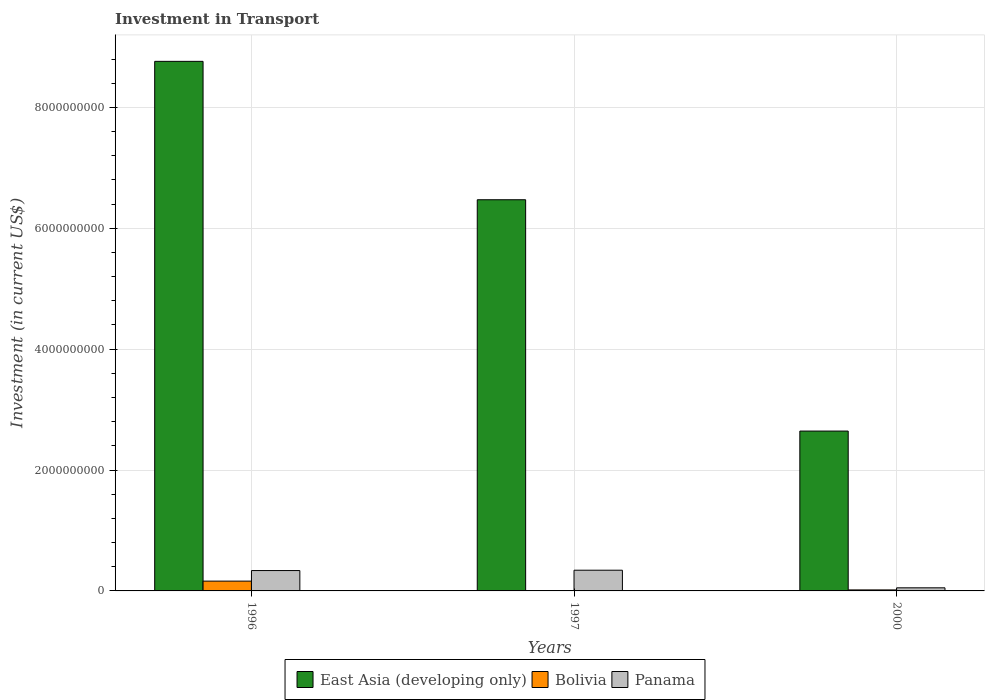Are the number of bars per tick equal to the number of legend labels?
Provide a succinct answer. Yes. Are the number of bars on each tick of the X-axis equal?
Your answer should be compact. Yes. How many bars are there on the 3rd tick from the right?
Your answer should be very brief. 3. In how many cases, is the number of bars for a given year not equal to the number of legend labels?
Provide a short and direct response. 0. What is the amount invested in transport in Bolivia in 1997?
Provide a succinct answer. 6.60e+06. Across all years, what is the maximum amount invested in transport in Panama?
Provide a succinct answer. 3.43e+08. Across all years, what is the minimum amount invested in transport in Bolivia?
Make the answer very short. 6.60e+06. In which year was the amount invested in transport in East Asia (developing only) maximum?
Keep it short and to the point. 1996. What is the total amount invested in transport in Panama in the graph?
Give a very brief answer. 7.31e+08. What is the difference between the amount invested in transport in East Asia (developing only) in 1996 and that in 2000?
Ensure brevity in your answer.  6.12e+09. What is the difference between the amount invested in transport in Bolivia in 2000 and the amount invested in transport in East Asia (developing only) in 1996?
Your answer should be compact. -8.74e+09. What is the average amount invested in transport in Bolivia per year?
Your response must be concise. 6.18e+07. In the year 1996, what is the difference between the amount invested in transport in Bolivia and amount invested in transport in East Asia (developing only)?
Make the answer very short. -8.60e+09. What is the ratio of the amount invested in transport in Panama in 1996 to that in 1997?
Ensure brevity in your answer.  0.98. Is the amount invested in transport in Bolivia in 1996 less than that in 1997?
Your response must be concise. No. What is the difference between the highest and the second highest amount invested in transport in Bolivia?
Make the answer very short. 1.46e+08. What is the difference between the highest and the lowest amount invested in transport in East Asia (developing only)?
Your response must be concise. 6.12e+09. What does the 1st bar from the left in 1997 represents?
Ensure brevity in your answer.  East Asia (developing only). What does the 3rd bar from the right in 2000 represents?
Keep it short and to the point. East Asia (developing only). How many years are there in the graph?
Provide a succinct answer. 3. What is the difference between two consecutive major ticks on the Y-axis?
Offer a very short reply. 2.00e+09. Does the graph contain any zero values?
Your response must be concise. No. How many legend labels are there?
Keep it short and to the point. 3. How are the legend labels stacked?
Ensure brevity in your answer.  Horizontal. What is the title of the graph?
Ensure brevity in your answer.  Investment in Transport. What is the label or title of the X-axis?
Provide a succinct answer. Years. What is the label or title of the Y-axis?
Make the answer very short. Investment (in current US$). What is the Investment (in current US$) in East Asia (developing only) in 1996?
Offer a very short reply. 8.76e+09. What is the Investment (in current US$) of Bolivia in 1996?
Keep it short and to the point. 1.62e+08. What is the Investment (in current US$) in Panama in 1996?
Give a very brief answer. 3.37e+08. What is the Investment (in current US$) of East Asia (developing only) in 1997?
Keep it short and to the point. 6.47e+09. What is the Investment (in current US$) of Bolivia in 1997?
Your answer should be compact. 6.60e+06. What is the Investment (in current US$) of Panama in 1997?
Provide a short and direct response. 3.43e+08. What is the Investment (in current US$) in East Asia (developing only) in 2000?
Give a very brief answer. 2.64e+09. What is the Investment (in current US$) of Bolivia in 2000?
Your answer should be very brief. 1.66e+07. What is the Investment (in current US$) in Panama in 2000?
Provide a succinct answer. 5.14e+07. Across all years, what is the maximum Investment (in current US$) of East Asia (developing only)?
Provide a short and direct response. 8.76e+09. Across all years, what is the maximum Investment (in current US$) in Bolivia?
Your response must be concise. 1.62e+08. Across all years, what is the maximum Investment (in current US$) of Panama?
Offer a terse response. 3.43e+08. Across all years, what is the minimum Investment (in current US$) of East Asia (developing only)?
Provide a short and direct response. 2.64e+09. Across all years, what is the minimum Investment (in current US$) in Bolivia?
Provide a succinct answer. 6.60e+06. Across all years, what is the minimum Investment (in current US$) in Panama?
Keep it short and to the point. 5.14e+07. What is the total Investment (in current US$) of East Asia (developing only) in the graph?
Give a very brief answer. 1.79e+1. What is the total Investment (in current US$) in Bolivia in the graph?
Keep it short and to the point. 1.85e+08. What is the total Investment (in current US$) of Panama in the graph?
Offer a very short reply. 7.31e+08. What is the difference between the Investment (in current US$) in East Asia (developing only) in 1996 and that in 1997?
Your response must be concise. 2.29e+09. What is the difference between the Investment (in current US$) in Bolivia in 1996 and that in 1997?
Provide a short and direct response. 1.56e+08. What is the difference between the Investment (in current US$) in Panama in 1996 and that in 1997?
Make the answer very short. -5.60e+06. What is the difference between the Investment (in current US$) of East Asia (developing only) in 1996 and that in 2000?
Give a very brief answer. 6.12e+09. What is the difference between the Investment (in current US$) of Bolivia in 1996 and that in 2000?
Give a very brief answer. 1.46e+08. What is the difference between the Investment (in current US$) in Panama in 1996 and that in 2000?
Offer a very short reply. 2.86e+08. What is the difference between the Investment (in current US$) of East Asia (developing only) in 1997 and that in 2000?
Keep it short and to the point. 3.83e+09. What is the difference between the Investment (in current US$) in Bolivia in 1997 and that in 2000?
Make the answer very short. -1.00e+07. What is the difference between the Investment (in current US$) in Panama in 1997 and that in 2000?
Provide a succinct answer. 2.91e+08. What is the difference between the Investment (in current US$) of East Asia (developing only) in 1996 and the Investment (in current US$) of Bolivia in 1997?
Your answer should be very brief. 8.75e+09. What is the difference between the Investment (in current US$) in East Asia (developing only) in 1996 and the Investment (in current US$) in Panama in 1997?
Keep it short and to the point. 8.42e+09. What is the difference between the Investment (in current US$) in Bolivia in 1996 and the Investment (in current US$) in Panama in 1997?
Provide a short and direct response. -1.80e+08. What is the difference between the Investment (in current US$) in East Asia (developing only) in 1996 and the Investment (in current US$) in Bolivia in 2000?
Give a very brief answer. 8.74e+09. What is the difference between the Investment (in current US$) of East Asia (developing only) in 1996 and the Investment (in current US$) of Panama in 2000?
Your answer should be very brief. 8.71e+09. What is the difference between the Investment (in current US$) in Bolivia in 1996 and the Investment (in current US$) in Panama in 2000?
Offer a very short reply. 1.11e+08. What is the difference between the Investment (in current US$) in East Asia (developing only) in 1997 and the Investment (in current US$) in Bolivia in 2000?
Your answer should be compact. 6.46e+09. What is the difference between the Investment (in current US$) in East Asia (developing only) in 1997 and the Investment (in current US$) in Panama in 2000?
Keep it short and to the point. 6.42e+09. What is the difference between the Investment (in current US$) of Bolivia in 1997 and the Investment (in current US$) of Panama in 2000?
Your answer should be very brief. -4.48e+07. What is the average Investment (in current US$) in East Asia (developing only) per year?
Provide a short and direct response. 5.96e+09. What is the average Investment (in current US$) in Bolivia per year?
Give a very brief answer. 6.18e+07. What is the average Investment (in current US$) of Panama per year?
Your answer should be compact. 2.44e+08. In the year 1996, what is the difference between the Investment (in current US$) in East Asia (developing only) and Investment (in current US$) in Bolivia?
Make the answer very short. 8.60e+09. In the year 1996, what is the difference between the Investment (in current US$) of East Asia (developing only) and Investment (in current US$) of Panama?
Offer a terse response. 8.42e+09. In the year 1996, what is the difference between the Investment (in current US$) of Bolivia and Investment (in current US$) of Panama?
Your response must be concise. -1.75e+08. In the year 1997, what is the difference between the Investment (in current US$) in East Asia (developing only) and Investment (in current US$) in Bolivia?
Your answer should be very brief. 6.47e+09. In the year 1997, what is the difference between the Investment (in current US$) of East Asia (developing only) and Investment (in current US$) of Panama?
Provide a short and direct response. 6.13e+09. In the year 1997, what is the difference between the Investment (in current US$) of Bolivia and Investment (in current US$) of Panama?
Your answer should be compact. -3.36e+08. In the year 2000, what is the difference between the Investment (in current US$) of East Asia (developing only) and Investment (in current US$) of Bolivia?
Your answer should be very brief. 2.63e+09. In the year 2000, what is the difference between the Investment (in current US$) of East Asia (developing only) and Investment (in current US$) of Panama?
Your response must be concise. 2.59e+09. In the year 2000, what is the difference between the Investment (in current US$) of Bolivia and Investment (in current US$) of Panama?
Provide a short and direct response. -3.48e+07. What is the ratio of the Investment (in current US$) of East Asia (developing only) in 1996 to that in 1997?
Give a very brief answer. 1.35. What is the ratio of the Investment (in current US$) of Bolivia in 1996 to that in 1997?
Your answer should be compact. 24.56. What is the ratio of the Investment (in current US$) in Panama in 1996 to that in 1997?
Your response must be concise. 0.98. What is the ratio of the Investment (in current US$) in East Asia (developing only) in 1996 to that in 2000?
Your answer should be compact. 3.31. What is the ratio of the Investment (in current US$) of Bolivia in 1996 to that in 2000?
Your response must be concise. 9.77. What is the ratio of the Investment (in current US$) of Panama in 1996 to that in 2000?
Provide a succinct answer. 6.56. What is the ratio of the Investment (in current US$) in East Asia (developing only) in 1997 to that in 2000?
Your answer should be very brief. 2.45. What is the ratio of the Investment (in current US$) of Bolivia in 1997 to that in 2000?
Offer a very short reply. 0.4. What is the ratio of the Investment (in current US$) in Panama in 1997 to that in 2000?
Offer a very short reply. 6.67. What is the difference between the highest and the second highest Investment (in current US$) of East Asia (developing only)?
Keep it short and to the point. 2.29e+09. What is the difference between the highest and the second highest Investment (in current US$) of Bolivia?
Give a very brief answer. 1.46e+08. What is the difference between the highest and the second highest Investment (in current US$) in Panama?
Make the answer very short. 5.60e+06. What is the difference between the highest and the lowest Investment (in current US$) of East Asia (developing only)?
Give a very brief answer. 6.12e+09. What is the difference between the highest and the lowest Investment (in current US$) of Bolivia?
Keep it short and to the point. 1.56e+08. What is the difference between the highest and the lowest Investment (in current US$) of Panama?
Your answer should be very brief. 2.91e+08. 